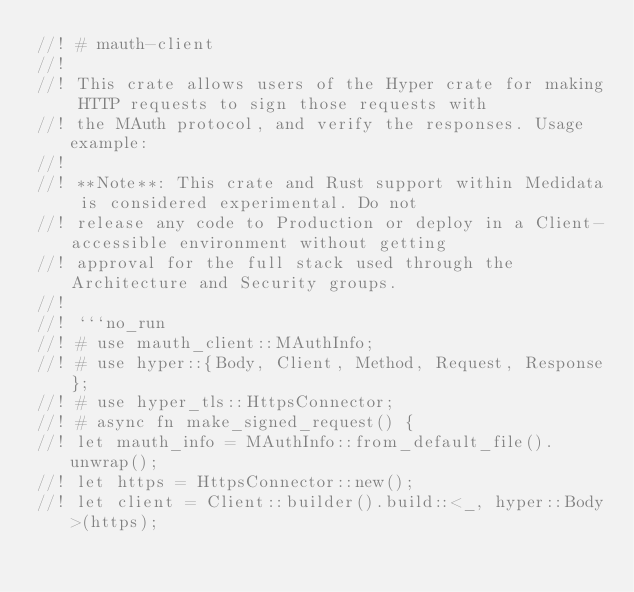<code> <loc_0><loc_0><loc_500><loc_500><_Rust_>//! # mauth-client
//!
//! This crate allows users of the Hyper crate for making HTTP requests to sign those requests with
//! the MAuth protocol, and verify the responses. Usage example:
//!
//! **Note**: This crate and Rust support within Medidata is considered experimental. Do not
//! release any code to Production or deploy in a Client-accessible environment without getting
//! approval for the full stack used through the Architecture and Security groups.
//!
//! ```no_run
//! # use mauth_client::MAuthInfo;
//! # use hyper::{Body, Client, Method, Request, Response};
//! # use hyper_tls::HttpsConnector;
//! # async fn make_signed_request() {
//! let mauth_info = MAuthInfo::from_default_file().unwrap();
//! let https = HttpsConnector::new();
//! let client = Client::builder().build::<_, hyper::Body>(https);</code> 